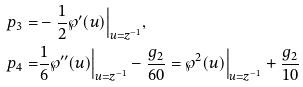<formula> <loc_0><loc_0><loc_500><loc_500>p _ { 3 } = & - \frac { 1 } { 2 } \wp ^ { \prime } ( u ) \Big { | } _ { u = z ^ { - 1 } } , \\ p _ { 4 } = & \frac { 1 } { 6 } \wp ^ { \prime \prime } ( u ) \Big { | } _ { u = z ^ { - 1 } } - \frac { g _ { 2 } } { 6 0 } = \wp ^ { 2 } ( u ) \Big { | } _ { u = z ^ { - 1 } } + \frac { g _ { 2 } } { 1 0 }</formula> 